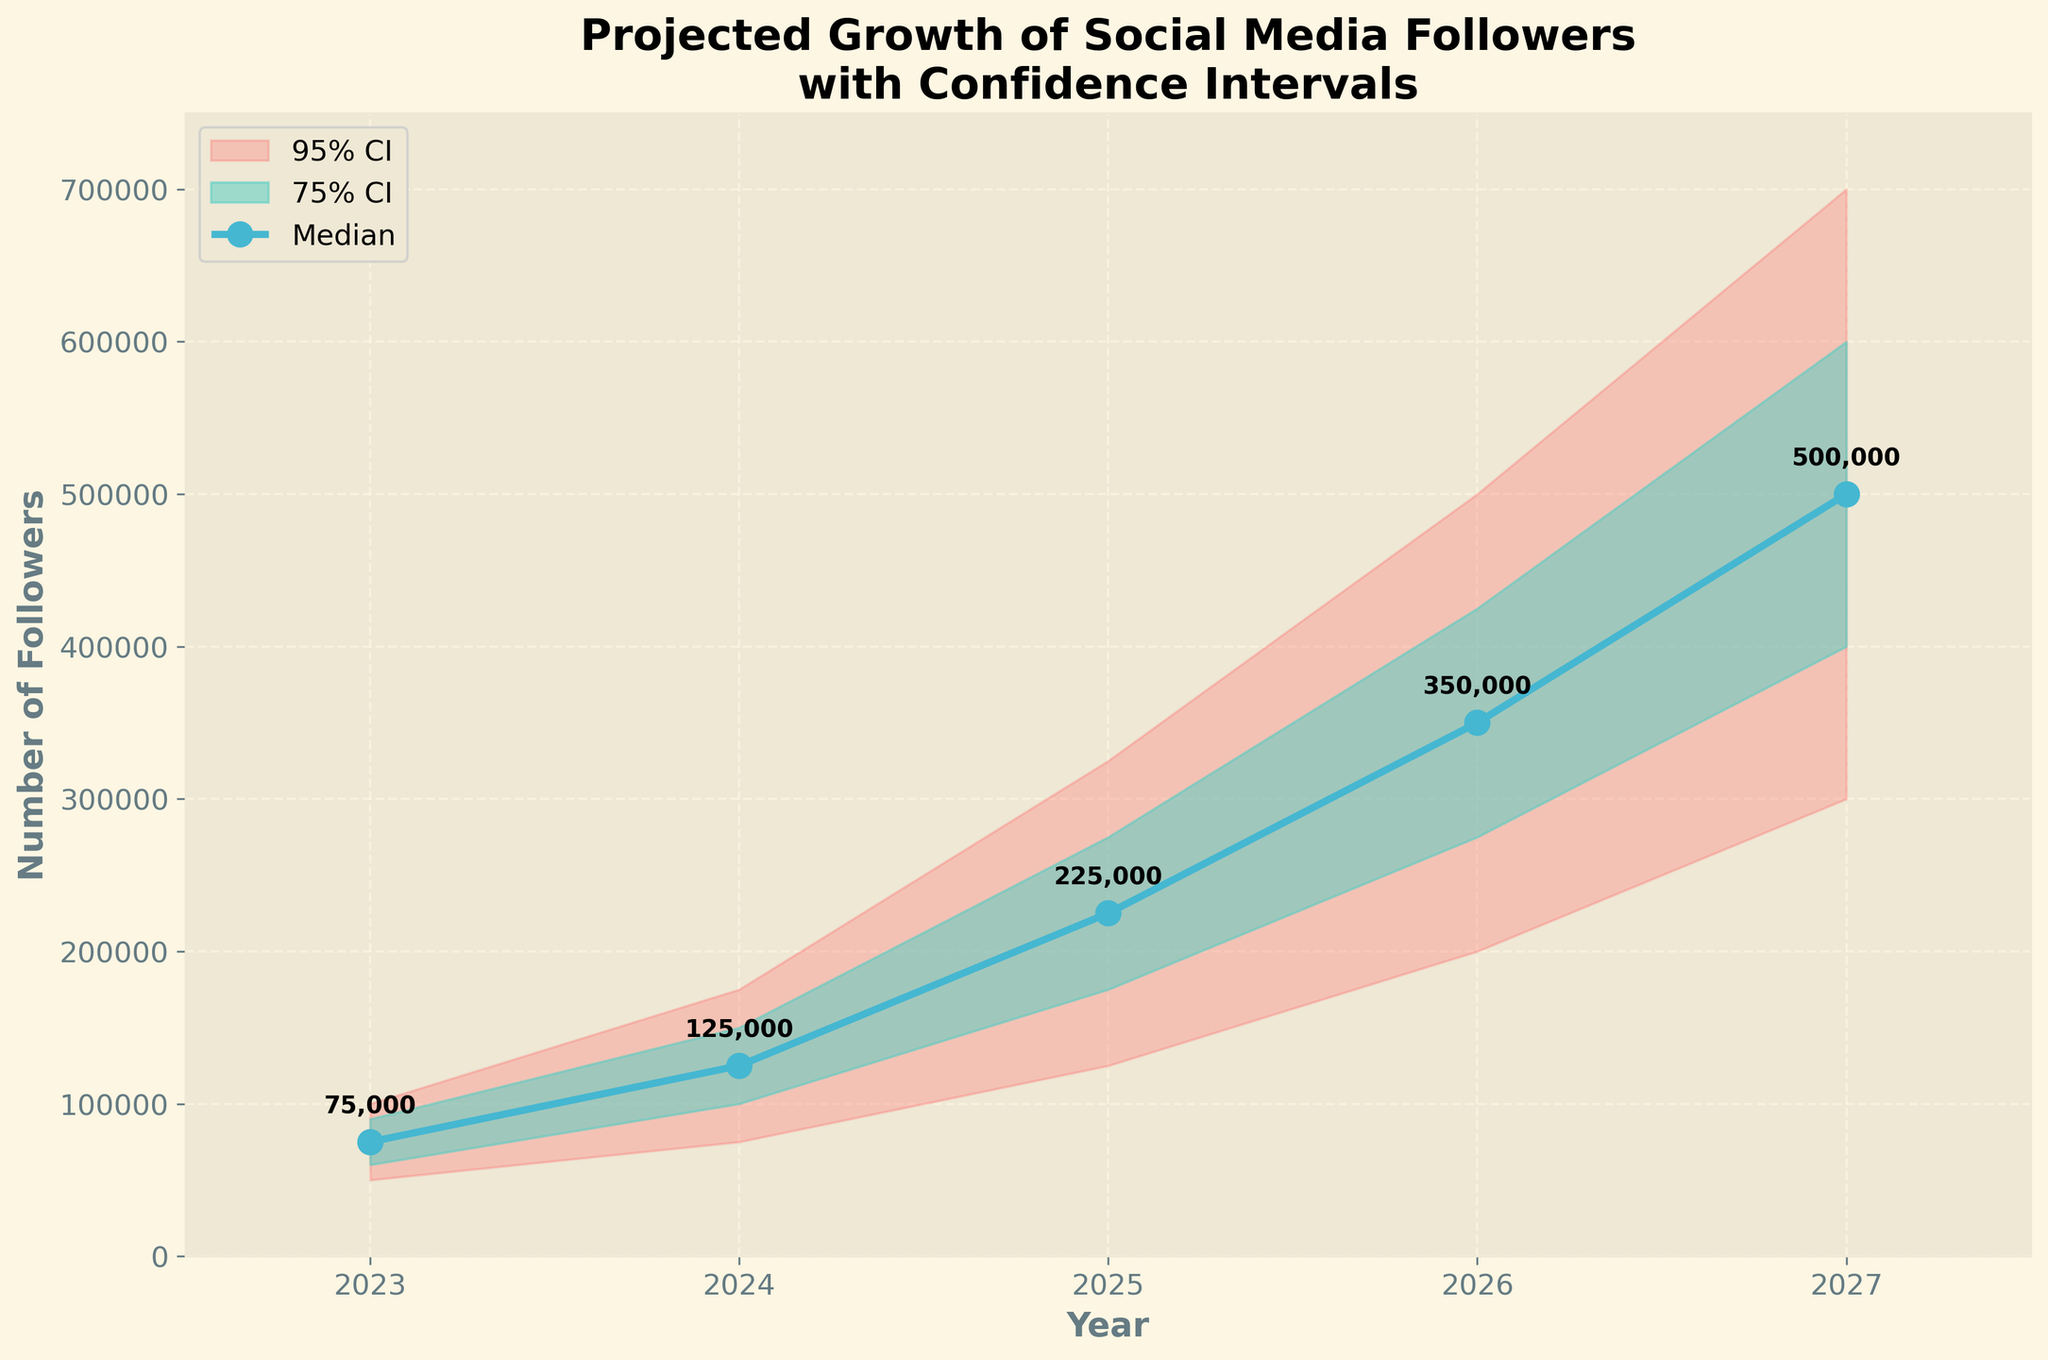What is the title of the plot? The title of the plot is usually found at the top and it summarizes what the plot is about. In this case, it shows "Projected Growth of Social Media Followers\nwith Confidence Intervals".
Answer: Projected Growth of Social Media Followers with Confidence Intervals What are the labels of the x-axis and y-axis? The x-axis typically represents the time period, while the y-axis represents the quantity being measured. The labels for the x-axis and y-axis are found directly next to each respective axis.
Answer: x-axis: Year, y-axis: Number of Followers What is the median projected number of social media followers in 2025? Locate the year 2025 on the x-axis, then find the corresponding median value represented by the line with circular markers and annotated with numbers.
Answer: 225,000 Between which years do the 95% confidence intervals expand the most? To determine this, compare the width of the 95% confidence interval bands between different years. The 95% CI is the outermost band.
Answer: Between 2024 and 2025 What is the maximum value of the 95% confidence interval in 2027? Locate the year 2027 on the x-axis, and then find the upper limit of the 95% confidence interval, which is represented by the upper edge of the outermost band.
Answer: 700,000 How does the median projected number of followers change from 2023 to 2024? Compare the median value (the central line with circular markers) for the years 2023 and 2024. The numbers are also annotated.
Answer: It increases from 75,000 to 125,000 Which year shows the widest range for the 75% confidence interval? To find the year with the widest 75% confidence interval, look at the width of the inner shaded band (slightly darker) for each year and compare.
Answer: 2025 What is the difference in the upper bound of the 75% confidence interval between 2023 and 2027? Identify the upper bound of the 75% confidence interval for both 2023 and 2027, and then subtract the 2023 value from the 2027 value.
Answer: 510,000 What trend can be observed in the median number of social media followers over the 5 years? Observe the median line (central line with markers) from 2023 to 2027. The trend can be derived from the year-to-year change.
Answer: Increasing Compare the projection accuracy between 2023 and 2027 by analyzing the confidence intervals. Which year has more uncertainty in the projection? Compare the width of both the 75% and 95% confidence intervals for the years 2023 and 2027. The wider the intervals, the higher the uncertainty.
Answer: 2027 